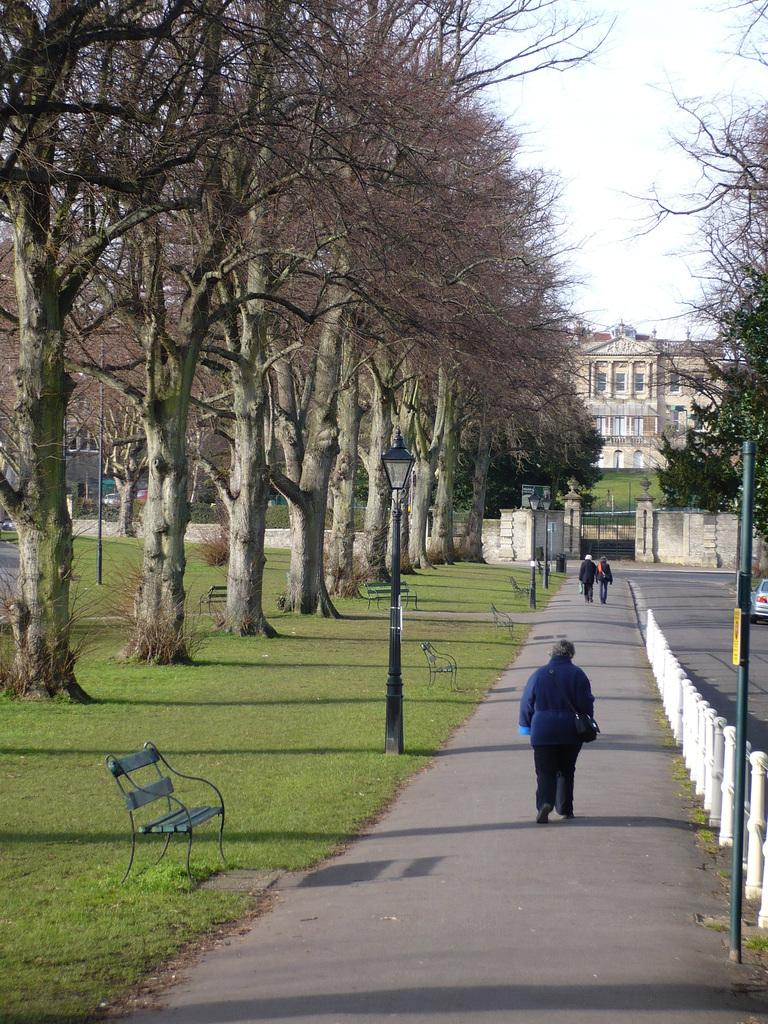What are the people in the image doing? The people in the image are walking on the road. What structures can be seen along the road? There are light poles and benches visible in the image. What type of vegetation is present in the image? There are trees in the image. What type of barrier is present in the image? There is fencing in the image. What can be seen in the background of the image? There is a building visible in the background, and windows are visible on the building. What is the color of the sky in the image? The sky appears to be white in color. Can you hear the sound of a horn coming from the building in the image? There is no sound present in the image, so it is not possible to hear a horn or any other sound. Are there any sparkling objects visible on the benches in the image? There are no sparkling objects visible on the benches or anywhere else in the image. 